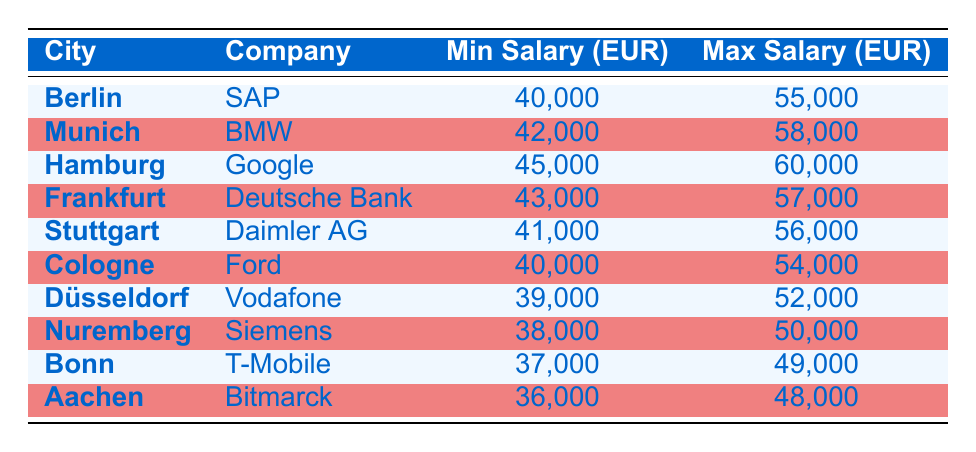What is the highest maximum salary offered for entry-level software engineers in Germany? Looking at the "Max Salary (EUR)" column, the highest value is 60000, which corresponds to Hamburg at Google.
Answer: 60000 What is the minimum salary for an entry-level software engineer at Vodafone in Düsseldorf? The "Min Salary (EUR)" for Vodafone in Düsseldorf is listed as 39000 in the table.
Answer: 39000 Which city offers the lowest maximum salary range for entry-level software engineers? Checking the "Max Salary (EUR)" values, Bonn has the lowest maximum salary of 49000.
Answer: Bonn What is the average minimum salary for entry-level software engineers in the listed cities? The minimum salaries are 40000, 42000, 45000, 43000, 41000, 40000, 39000, 38000, 37000, and 36000. The total is 401000, and there are 10 cities. Therefore, the average is 401000 divided by 10, which equals 40100.
Answer: 40100 Is the minimum salary for an entry-level software engineer at SAP in Berlin higher than at T-Mobile in Bonn? The minimum salary for SAP in Berlin is 40000, while for T-Mobile in Bonn, it is 37000. Since 40000 is indeed higher than 37000, the answer is yes.
Answer: Yes What is the difference in maximum salary between BMW in Munich and Daimler AG in Stuttgart? The maximum salary for BMW in Munich is 58000 and for Daimler AG in Stuttgart is 56000. The difference is 58000 minus 56000, which equals 2000.
Answer: 2000 Are the salary ranges for entry-level software engineers in both Hamburg and Frankfurt higher than 45000? The maximum salary in Hamburg is 60000 and in Frankfurt it is 57000. Since both values are greater than 45000, the answer is yes.
Answer: Yes Which city has a higher salary range between Aachen and Nuremberg? In Aachen, the minimum is 36000 and maximum is 48000; in Nuremberg, the minimum is 38000 and maximum is 50000. Comparatively, Nuremberg's maximum salary of 50000 is higher than Aachen's 48000.
Answer: Nuremberg What salary range should an entry-level software engineer expect in Cologne at Ford? The "SalaryRange" for Ford in Cologne shows a minimum of 40000 and a maximum of 54000.
Answer: 40000 to 54000 